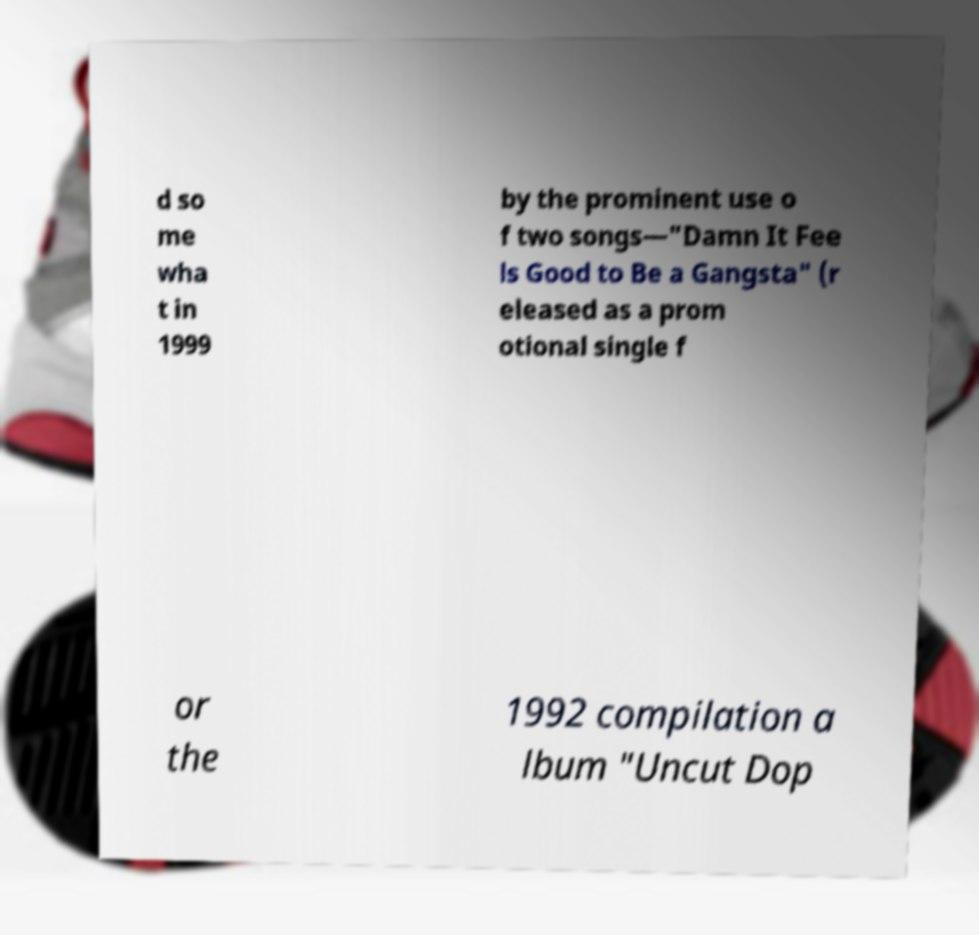Please read and relay the text visible in this image. What does it say? d so me wha t in 1999 by the prominent use o f two songs—"Damn It Fee ls Good to Be a Gangsta" (r eleased as a prom otional single f or the 1992 compilation a lbum "Uncut Dop 